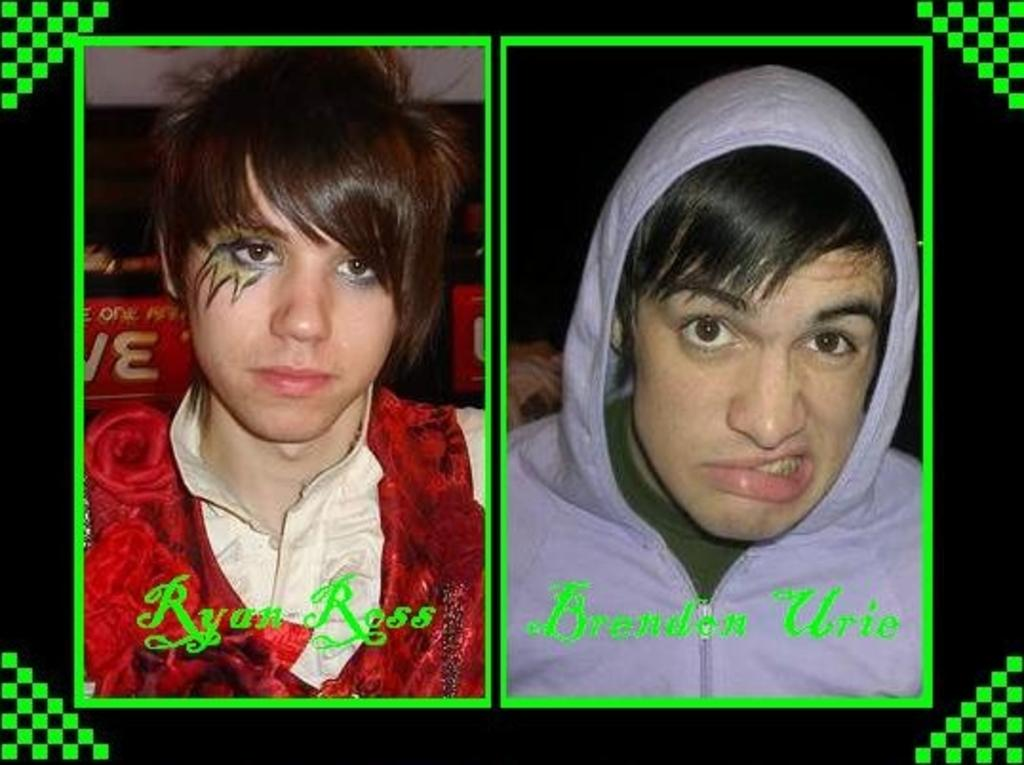Who are the people depicted in the image? There are pictures of two people in the image. What else can be seen in the image besides the pictures of the people? There is text in the image. What type of wool is being discussed by the people in the image? There is no wool or discussion about wool present in the image. How many kittens are visible in the image? There are no kittens present in the image. 